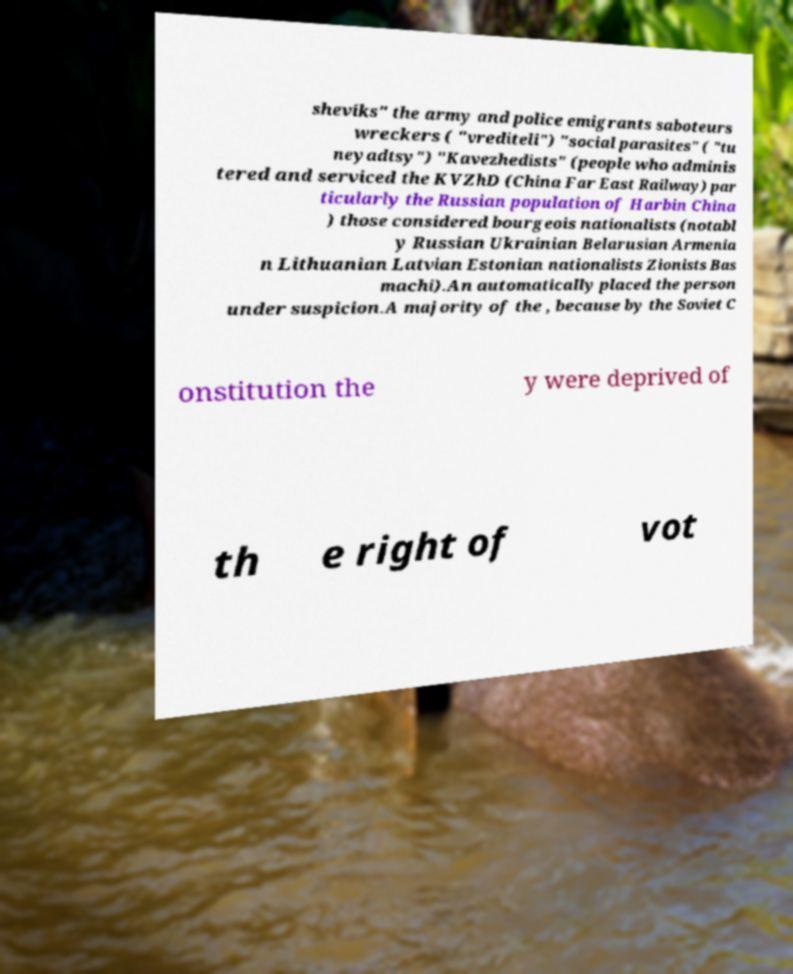For documentation purposes, I need the text within this image transcribed. Could you provide that? sheviks" the army and police emigrants saboteurs wreckers ( "vrediteli") "social parasites" ( "tu neyadtsy") "Kavezhedists" (people who adminis tered and serviced the KVZhD (China Far East Railway) par ticularly the Russian population of Harbin China ) those considered bourgeois nationalists (notabl y Russian Ukrainian Belarusian Armenia n Lithuanian Latvian Estonian nationalists Zionists Bas machi).An automatically placed the person under suspicion.A majority of the , because by the Soviet C onstitution the y were deprived of th e right of vot 